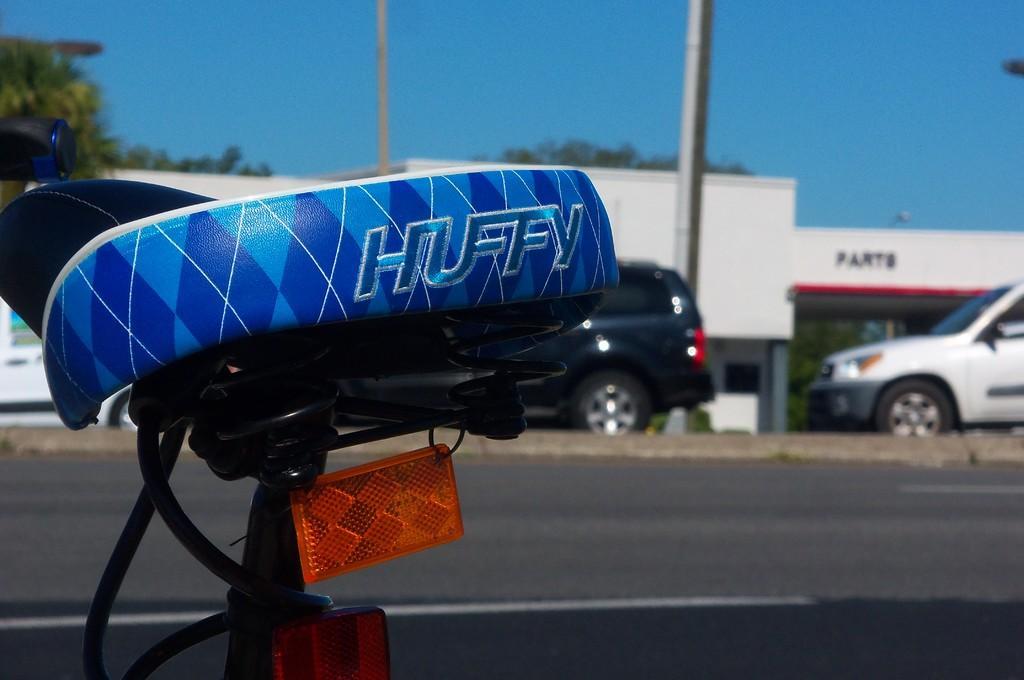Describe this image in one or two sentences. In this image there is a seat of a bicycle and a road, behind the road there are cars parked, in the background there is shop, trees and blue sky. 